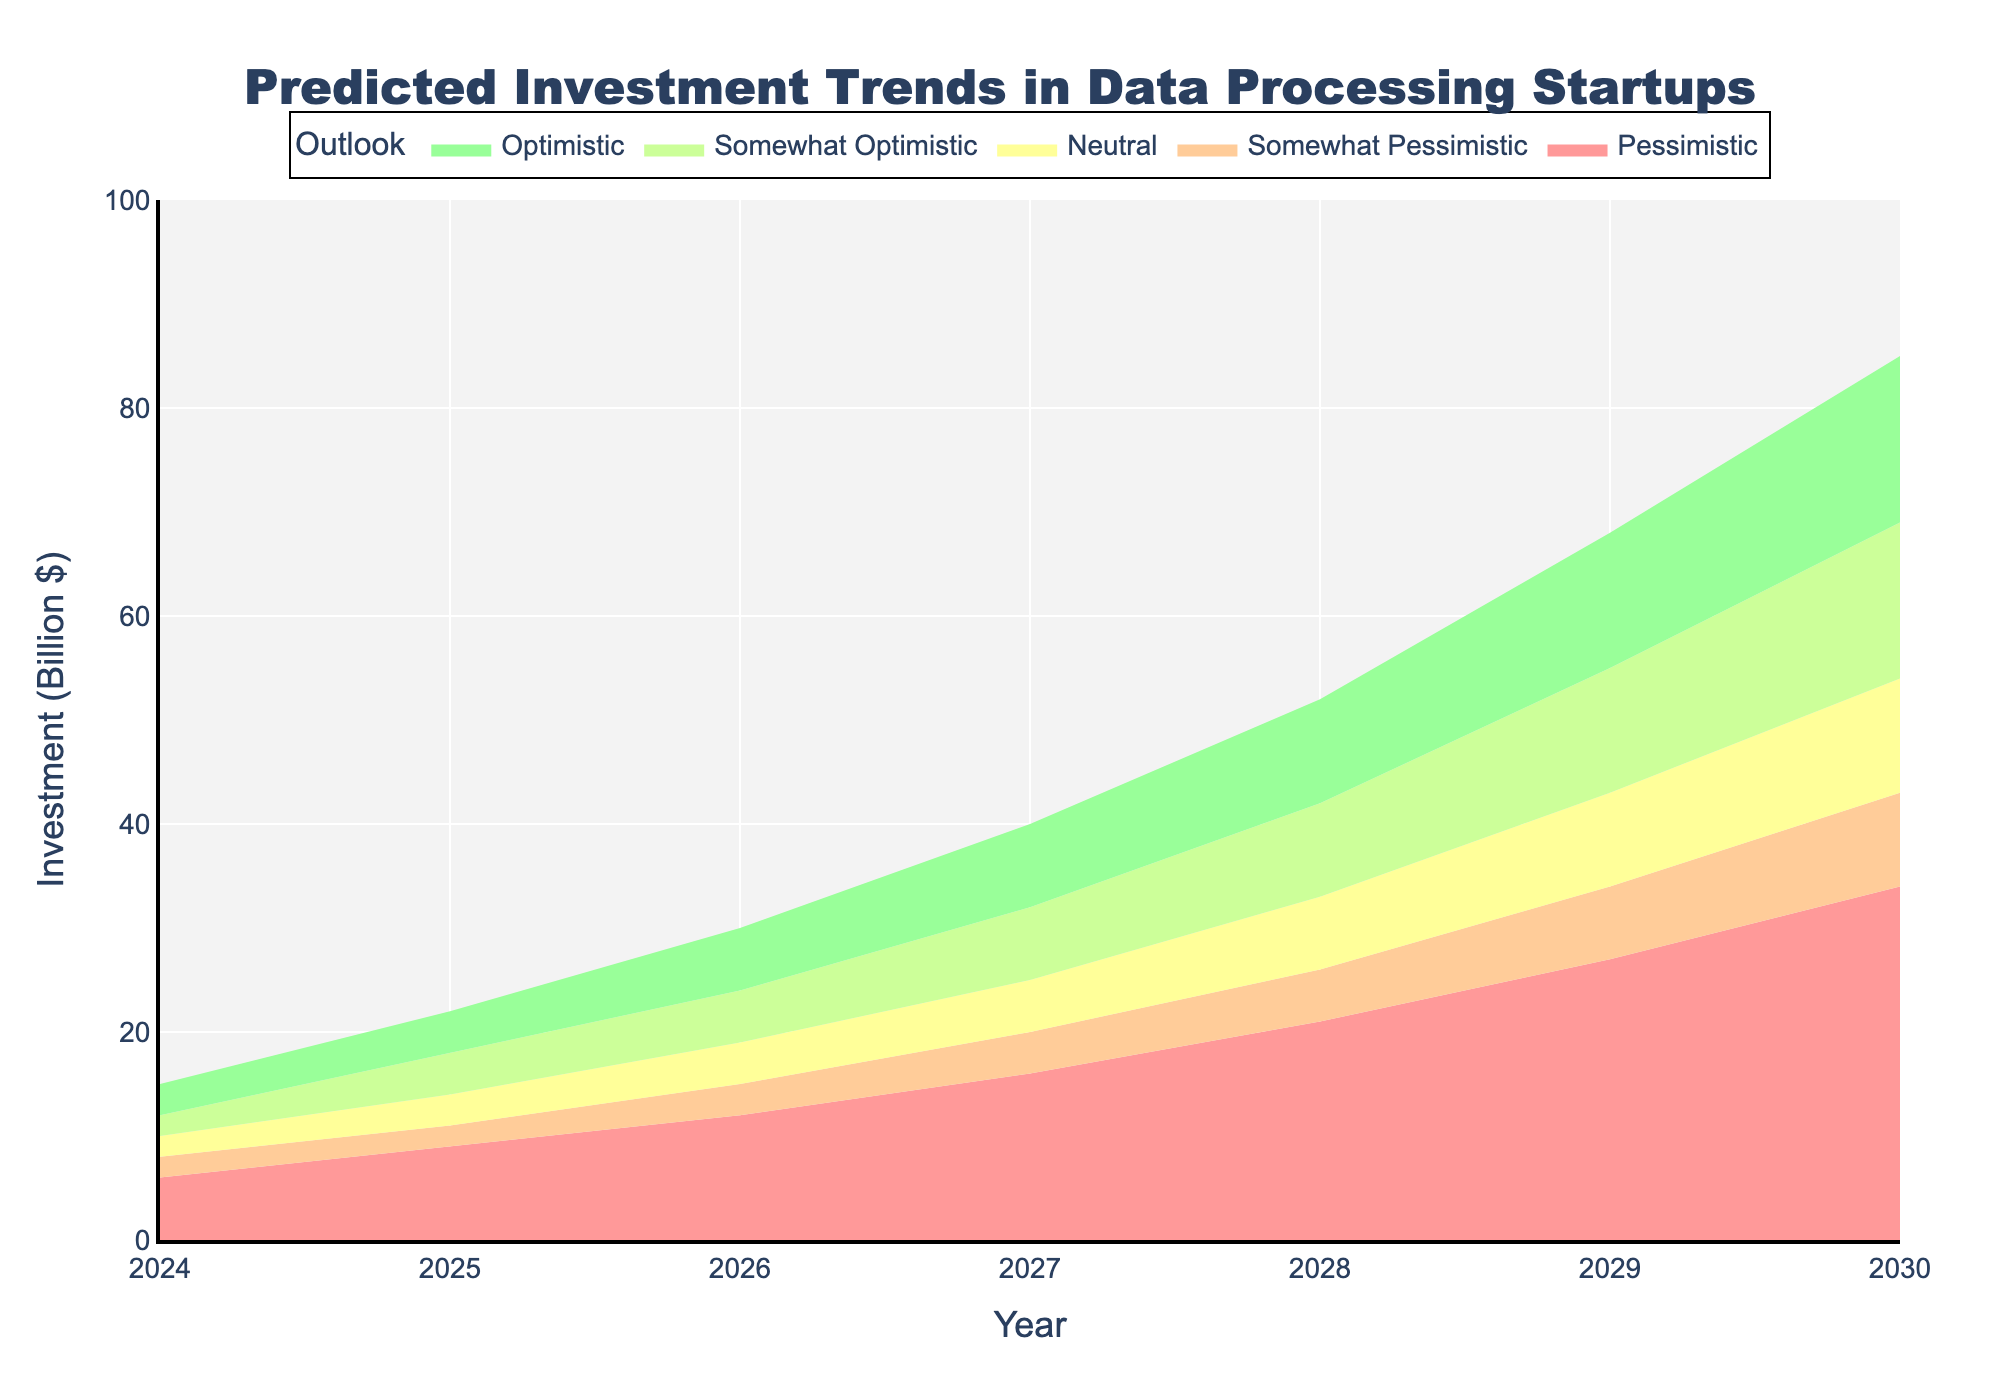what is the title of the chart? The title is located at the top of the chart. It reads "Predicted Investment Trends in Data Processing Startups".
Answer: Predicted Investment Trends in Data Processing Startups What does the x-axis represent? The x-axis label is "Year," indicating that the horizontal axis represents the years from 2024 to 2030.
Answer: Year What is the investment prediction for the year 2026 under the neutral outlook? The value for the neutral outlook in 2026 is shown by following the "Neutral" trace directly above the year 2026.
Answer: 19 billion dollars What is the difference in investment between the optimistic and pessimistic outlooks for the year 2029? The investment under the optimistic outlook for 2029 is 68 billion dollars. The pessimistic outlook for the same year is 27 billion dollars. The difference is 68 - 27.
Answer: 41 billion dollars Which outlook predicts the highest investment in 2030? The highest trace for the year 2030 is the optimistic outlook, marked by the topmost line on the chart.
Answer: Optimistic Between which years does the somewhat optimistic outlook predict an increase in investment from approximately 18 to 69 billion dollars? The investment for the somewhat optimistic outlook increases from 18 billion dollars in 2025 to 69 billion dollars in 2030.
Answer: 2025 to 2030 In which year is the predicted investment the smallest under the pessimistic outlook? The smallest predicted investment under the pessimistic outlook is in 2024, as indicated by the lowest point on the chart.
Answer: 2024 What is the average predicted investment for the neutral outlook from 2024 to 2030? The neutral outlook investment values are 10, 14, 19, 25, 33, 43, and 54 billion dollars. The sum is 198 billion dollars, and there are 7 years. Therefore, the average is 198 / 7.
Answer: 28.29 billion dollars By how much does the somewhat pessimistic outlook for 2027 differ from the neutral outlook for the same year? The investment under the somewhat pessimistic outlook for 2027 is 20 billion dollars and the neutral outlook is 25 billion dollars. The difference is 25 - 20.
Answer: 5 billion dollars Which outlook shows the most significant increase in investment from 2024 to 2026? The optimistic outlook increases from 15 billion dollars in 2024 to 30 billion dollars in 2026, an increase of 15 billion dollars. This is the highest compared to other outlooks for the same period.
Answer: Optimistic 